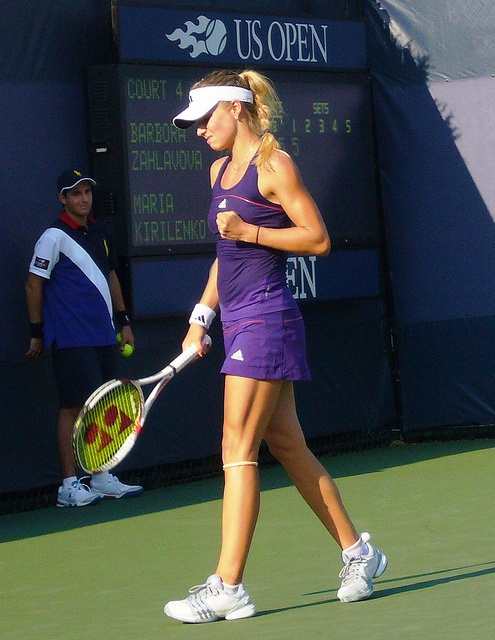Describe the objects in this image and their specific colors. I can see people in black, tan, white, and navy tones, people in black, navy, darkgray, and maroon tones, tennis racket in black, olive, white, and maroon tones, and sports ball in black, olive, and darkgreen tones in this image. 